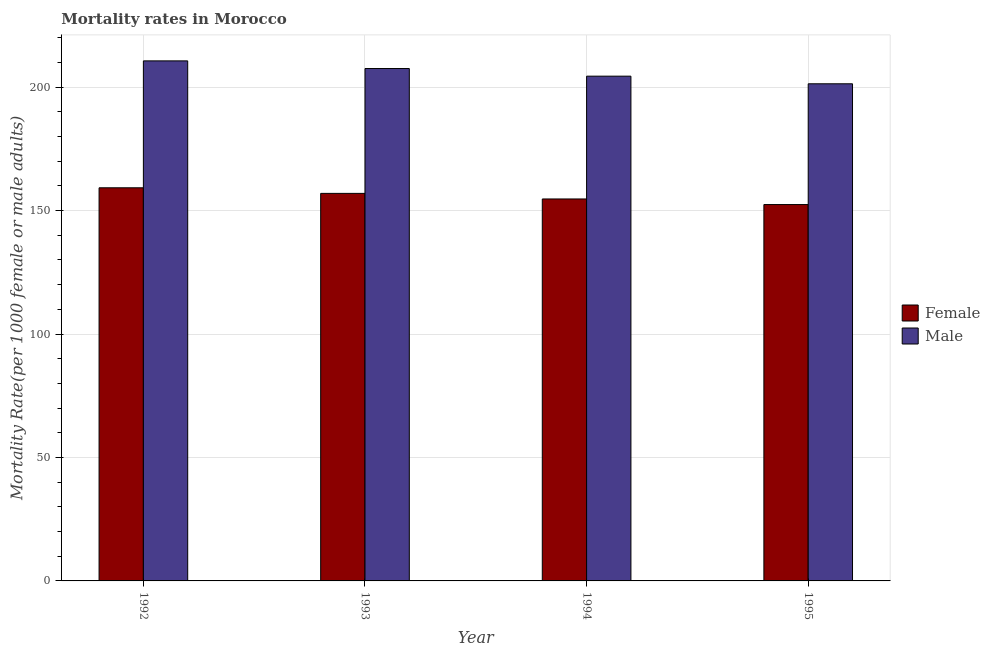How many different coloured bars are there?
Offer a terse response. 2. Are the number of bars on each tick of the X-axis equal?
Give a very brief answer. Yes. In how many cases, is the number of bars for a given year not equal to the number of legend labels?
Give a very brief answer. 0. What is the female mortality rate in 1992?
Offer a terse response. 159.23. Across all years, what is the maximum female mortality rate?
Your response must be concise. 159.23. Across all years, what is the minimum female mortality rate?
Keep it short and to the point. 152.44. In which year was the female mortality rate maximum?
Give a very brief answer. 1992. What is the total female mortality rate in the graph?
Give a very brief answer. 623.36. What is the difference between the female mortality rate in 1993 and that in 1995?
Your answer should be compact. 4.53. What is the difference between the female mortality rate in 1994 and the male mortality rate in 1995?
Offer a terse response. 2.26. What is the average female mortality rate per year?
Provide a short and direct response. 155.84. In the year 1995, what is the difference between the male mortality rate and female mortality rate?
Make the answer very short. 0. In how many years, is the male mortality rate greater than 60?
Provide a succinct answer. 4. What is the ratio of the female mortality rate in 1992 to that in 1993?
Provide a succinct answer. 1.01. Is the difference between the female mortality rate in 1992 and 1994 greater than the difference between the male mortality rate in 1992 and 1994?
Ensure brevity in your answer.  No. What is the difference between the highest and the second highest female mortality rate?
Offer a very short reply. 2.26. What is the difference between the highest and the lowest female mortality rate?
Make the answer very short. 6.79. What does the 1st bar from the left in 1993 represents?
Provide a succinct answer. Female. What does the 1st bar from the right in 1995 represents?
Your answer should be very brief. Male. How many years are there in the graph?
Your answer should be very brief. 4. What is the difference between two consecutive major ticks on the Y-axis?
Your response must be concise. 50. Are the values on the major ticks of Y-axis written in scientific E-notation?
Give a very brief answer. No. Does the graph contain any zero values?
Offer a terse response. No. Does the graph contain grids?
Ensure brevity in your answer.  Yes. How many legend labels are there?
Offer a terse response. 2. How are the legend labels stacked?
Your answer should be compact. Vertical. What is the title of the graph?
Offer a terse response. Mortality rates in Morocco. Does "Researchers" appear as one of the legend labels in the graph?
Your response must be concise. No. What is the label or title of the X-axis?
Provide a short and direct response. Year. What is the label or title of the Y-axis?
Your answer should be very brief. Mortality Rate(per 1000 female or male adults). What is the Mortality Rate(per 1000 female or male adults) in Female in 1992?
Your answer should be compact. 159.23. What is the Mortality Rate(per 1000 female or male adults) in Male in 1992?
Your answer should be compact. 210.64. What is the Mortality Rate(per 1000 female or male adults) in Female in 1993?
Keep it short and to the point. 156.97. What is the Mortality Rate(per 1000 female or male adults) of Male in 1993?
Provide a short and direct response. 207.54. What is the Mortality Rate(per 1000 female or male adults) in Female in 1994?
Provide a succinct answer. 154.71. What is the Mortality Rate(per 1000 female or male adults) of Male in 1994?
Your answer should be very brief. 204.45. What is the Mortality Rate(per 1000 female or male adults) in Female in 1995?
Your response must be concise. 152.44. What is the Mortality Rate(per 1000 female or male adults) in Male in 1995?
Your response must be concise. 201.36. Across all years, what is the maximum Mortality Rate(per 1000 female or male adults) in Female?
Give a very brief answer. 159.23. Across all years, what is the maximum Mortality Rate(per 1000 female or male adults) in Male?
Keep it short and to the point. 210.64. Across all years, what is the minimum Mortality Rate(per 1000 female or male adults) of Female?
Your answer should be compact. 152.44. Across all years, what is the minimum Mortality Rate(per 1000 female or male adults) of Male?
Provide a short and direct response. 201.36. What is the total Mortality Rate(per 1000 female or male adults) in Female in the graph?
Give a very brief answer. 623.36. What is the total Mortality Rate(per 1000 female or male adults) in Male in the graph?
Offer a very short reply. 823.99. What is the difference between the Mortality Rate(per 1000 female or male adults) in Female in 1992 and that in 1993?
Your answer should be compact. 2.26. What is the difference between the Mortality Rate(per 1000 female or male adults) in Male in 1992 and that in 1993?
Offer a very short reply. 3.1. What is the difference between the Mortality Rate(per 1000 female or male adults) of Female in 1992 and that in 1994?
Make the answer very short. 4.53. What is the difference between the Mortality Rate(per 1000 female or male adults) of Male in 1992 and that in 1994?
Your answer should be very brief. 6.19. What is the difference between the Mortality Rate(per 1000 female or male adults) in Female in 1992 and that in 1995?
Your answer should be very brief. 6.79. What is the difference between the Mortality Rate(per 1000 female or male adults) of Male in 1992 and that in 1995?
Give a very brief answer. 9.28. What is the difference between the Mortality Rate(per 1000 female or male adults) of Female in 1993 and that in 1994?
Give a very brief answer. 2.26. What is the difference between the Mortality Rate(per 1000 female or male adults) of Male in 1993 and that in 1994?
Offer a terse response. 3.09. What is the difference between the Mortality Rate(per 1000 female or male adults) in Female in 1993 and that in 1995?
Your response must be concise. 4.53. What is the difference between the Mortality Rate(per 1000 female or male adults) of Male in 1993 and that in 1995?
Your response must be concise. 6.19. What is the difference between the Mortality Rate(per 1000 female or male adults) of Female in 1994 and that in 1995?
Your response must be concise. 2.26. What is the difference between the Mortality Rate(per 1000 female or male adults) of Male in 1994 and that in 1995?
Ensure brevity in your answer.  3.09. What is the difference between the Mortality Rate(per 1000 female or male adults) of Female in 1992 and the Mortality Rate(per 1000 female or male adults) of Male in 1993?
Provide a succinct answer. -48.31. What is the difference between the Mortality Rate(per 1000 female or male adults) in Female in 1992 and the Mortality Rate(per 1000 female or male adults) in Male in 1994?
Your answer should be very brief. -45.22. What is the difference between the Mortality Rate(per 1000 female or male adults) of Female in 1992 and the Mortality Rate(per 1000 female or male adults) of Male in 1995?
Give a very brief answer. -42.12. What is the difference between the Mortality Rate(per 1000 female or male adults) in Female in 1993 and the Mortality Rate(per 1000 female or male adults) in Male in 1994?
Give a very brief answer. -47.48. What is the difference between the Mortality Rate(per 1000 female or male adults) of Female in 1993 and the Mortality Rate(per 1000 female or male adults) of Male in 1995?
Keep it short and to the point. -44.39. What is the difference between the Mortality Rate(per 1000 female or male adults) of Female in 1994 and the Mortality Rate(per 1000 female or male adults) of Male in 1995?
Ensure brevity in your answer.  -46.65. What is the average Mortality Rate(per 1000 female or male adults) of Female per year?
Your response must be concise. 155.84. What is the average Mortality Rate(per 1000 female or male adults) of Male per year?
Ensure brevity in your answer.  206. In the year 1992, what is the difference between the Mortality Rate(per 1000 female or male adults) of Female and Mortality Rate(per 1000 female or male adults) of Male?
Your response must be concise. -51.41. In the year 1993, what is the difference between the Mortality Rate(per 1000 female or male adults) in Female and Mortality Rate(per 1000 female or male adults) in Male?
Your response must be concise. -50.58. In the year 1994, what is the difference between the Mortality Rate(per 1000 female or male adults) of Female and Mortality Rate(per 1000 female or male adults) of Male?
Keep it short and to the point. -49.74. In the year 1995, what is the difference between the Mortality Rate(per 1000 female or male adults) in Female and Mortality Rate(per 1000 female or male adults) in Male?
Provide a short and direct response. -48.91. What is the ratio of the Mortality Rate(per 1000 female or male adults) of Female in 1992 to that in 1993?
Your answer should be compact. 1.01. What is the ratio of the Mortality Rate(per 1000 female or male adults) of Male in 1992 to that in 1993?
Give a very brief answer. 1.01. What is the ratio of the Mortality Rate(per 1000 female or male adults) in Female in 1992 to that in 1994?
Make the answer very short. 1.03. What is the ratio of the Mortality Rate(per 1000 female or male adults) in Male in 1992 to that in 1994?
Your answer should be very brief. 1.03. What is the ratio of the Mortality Rate(per 1000 female or male adults) of Female in 1992 to that in 1995?
Keep it short and to the point. 1.04. What is the ratio of the Mortality Rate(per 1000 female or male adults) in Male in 1992 to that in 1995?
Your answer should be very brief. 1.05. What is the ratio of the Mortality Rate(per 1000 female or male adults) in Female in 1993 to that in 1994?
Provide a succinct answer. 1.01. What is the ratio of the Mortality Rate(per 1000 female or male adults) of Male in 1993 to that in 1994?
Provide a succinct answer. 1.02. What is the ratio of the Mortality Rate(per 1000 female or male adults) in Female in 1993 to that in 1995?
Give a very brief answer. 1.03. What is the ratio of the Mortality Rate(per 1000 female or male adults) of Male in 1993 to that in 1995?
Offer a terse response. 1.03. What is the ratio of the Mortality Rate(per 1000 female or male adults) of Female in 1994 to that in 1995?
Keep it short and to the point. 1.01. What is the ratio of the Mortality Rate(per 1000 female or male adults) of Male in 1994 to that in 1995?
Your answer should be very brief. 1.02. What is the difference between the highest and the second highest Mortality Rate(per 1000 female or male adults) in Female?
Ensure brevity in your answer.  2.26. What is the difference between the highest and the second highest Mortality Rate(per 1000 female or male adults) in Male?
Make the answer very short. 3.1. What is the difference between the highest and the lowest Mortality Rate(per 1000 female or male adults) in Female?
Give a very brief answer. 6.79. What is the difference between the highest and the lowest Mortality Rate(per 1000 female or male adults) of Male?
Ensure brevity in your answer.  9.28. 